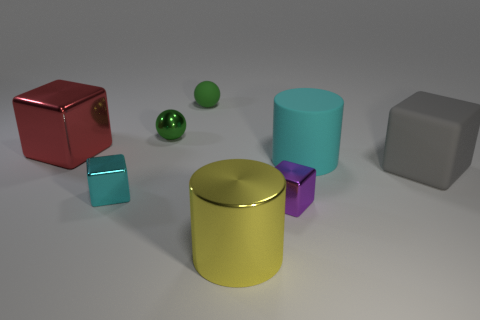How might the colors of the objects influence a viewer's perception? The diverse colors can evoke different emotions or draw attention in various ways. A red object might be perceived as bold or commanding attention, while the blue and green shades impart a more calming effect. These colors also create contrast with each other, which can make the composition more visually engaging and highlight the unique shape of each object. 